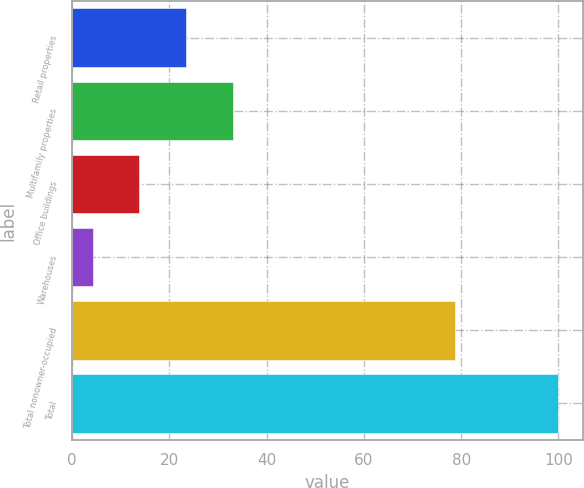Convert chart to OTSL. <chart><loc_0><loc_0><loc_500><loc_500><bar_chart><fcel>Retail properties<fcel>Multifamily properties<fcel>Office buildings<fcel>Warehouses<fcel>Total nonowner-occupied<fcel>Total<nl><fcel>23.44<fcel>33.01<fcel>13.87<fcel>4.3<fcel>78.8<fcel>100<nl></chart> 